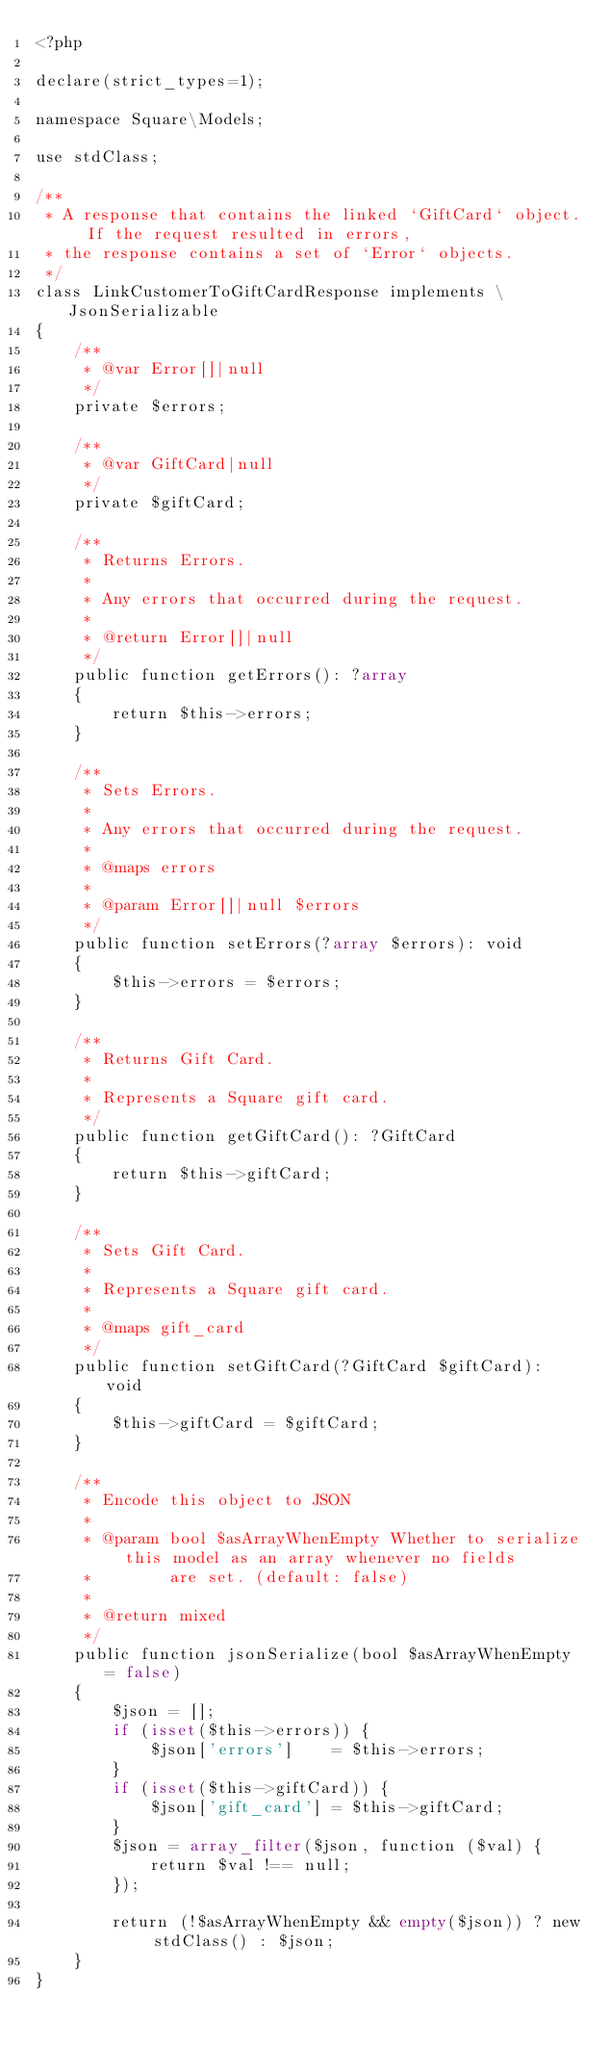Convert code to text. <code><loc_0><loc_0><loc_500><loc_500><_PHP_><?php

declare(strict_types=1);

namespace Square\Models;

use stdClass;

/**
 * A response that contains the linked `GiftCard` object. If the request resulted in errors,
 * the response contains a set of `Error` objects.
 */
class LinkCustomerToGiftCardResponse implements \JsonSerializable
{
    /**
     * @var Error[]|null
     */
    private $errors;

    /**
     * @var GiftCard|null
     */
    private $giftCard;

    /**
     * Returns Errors.
     *
     * Any errors that occurred during the request.
     *
     * @return Error[]|null
     */
    public function getErrors(): ?array
    {
        return $this->errors;
    }

    /**
     * Sets Errors.
     *
     * Any errors that occurred during the request.
     *
     * @maps errors
     *
     * @param Error[]|null $errors
     */
    public function setErrors(?array $errors): void
    {
        $this->errors = $errors;
    }

    /**
     * Returns Gift Card.
     *
     * Represents a Square gift card.
     */
    public function getGiftCard(): ?GiftCard
    {
        return $this->giftCard;
    }

    /**
     * Sets Gift Card.
     *
     * Represents a Square gift card.
     *
     * @maps gift_card
     */
    public function setGiftCard(?GiftCard $giftCard): void
    {
        $this->giftCard = $giftCard;
    }

    /**
     * Encode this object to JSON
     *
     * @param bool $asArrayWhenEmpty Whether to serialize this model as an array whenever no fields
     *        are set. (default: false)
     *
     * @return mixed
     */
    public function jsonSerialize(bool $asArrayWhenEmpty = false)
    {
        $json = [];
        if (isset($this->errors)) {
            $json['errors']    = $this->errors;
        }
        if (isset($this->giftCard)) {
            $json['gift_card'] = $this->giftCard;
        }
        $json = array_filter($json, function ($val) {
            return $val !== null;
        });

        return (!$asArrayWhenEmpty && empty($json)) ? new stdClass() : $json;
    }
}
</code> 